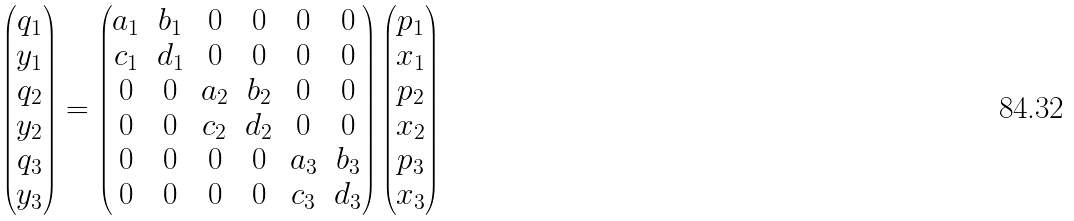Convert formula to latex. <formula><loc_0><loc_0><loc_500><loc_500>\begin{pmatrix} q _ { 1 } \\ y _ { 1 } \\ q _ { 2 } \\ y _ { 2 } \\ q _ { 3 } \\ y _ { 3 } \end{pmatrix} = \begin{pmatrix} a _ { 1 } & b _ { 1 } & 0 & 0 & 0 & 0 \\ c _ { 1 } & d _ { 1 } & 0 & 0 & 0 & 0 \\ 0 & 0 & a _ { 2 } & b _ { 2 } & 0 & 0 \\ 0 & 0 & c _ { 2 } & d _ { 2 } & 0 & 0 \\ 0 & 0 & 0 & 0 & a _ { 3 } & b _ { 3 } \\ 0 & 0 & 0 & 0 & c _ { 3 } & d _ { 3 } \end{pmatrix} \begin{pmatrix} p _ { 1 } \\ x _ { 1 } \\ p _ { 2 } \\ x _ { 2 } \\ p _ { 3 } \\ x _ { 3 } \end{pmatrix}</formula> 